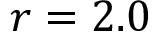<formula> <loc_0><loc_0><loc_500><loc_500>r = 2 . 0</formula> 